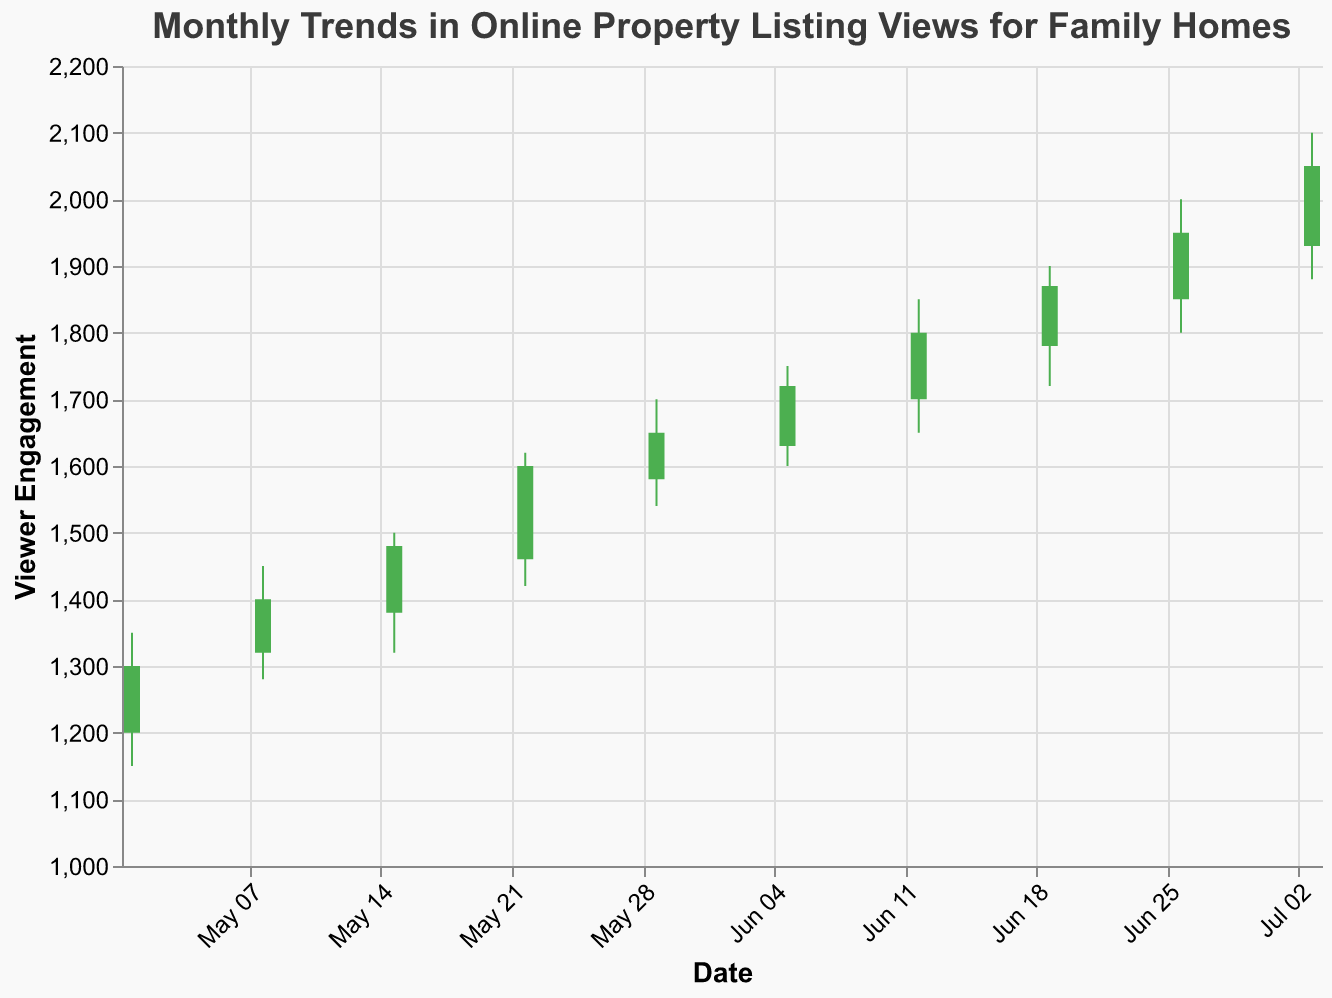What is the title of the chart? The title is at the top of the chart and clearly states the purpose of the visualization.
Answer: Monthly Trends in Online Property Listing Views for Family Homes How many data points are displayed in the chart? There are dates labeled on the x-axis, and each date likely corresponds to one data point. By counting the dates, we find there are 10 data points.
Answer: 10 What are the colors used to represent increasing and decreasing viewer engagement? In the chart, a green color is used to represent an increase where the close value is higher than the open value, and a red color is used for a decrease where the close value is lower than the open value.
Answer: Green and Red On which date was viewer engagement the highest during the month of May? By examining the "High" values for dates in May and comparing them, we find that the highest engagement was on May 22 with a high value of 1620.
Answer: May 22 Which week had the lowest level of viewer engagement? We need to find the minimum "Low" value across all data points and identify the corresponding date. The lowest engagement is on May 1 with a low value of 1150.
Answer: May 1 Calculate the difference between the highest and lowest viewer engagement in June. To find this, identify the highest high and the lowest low values in June. The highest high is 2000 (June 26) and the lowest low is 1600 (June 5). The difference is 2000 - 1600 = 400.
Answer: 400 Which week experienced the greatest increase in viewer engagement? We need to find the week where the difference between the close and open values is the maximum. The week of June 19 had an increase of 90 (Close - Open = 1870 - 1780).
Answer: June 19 On which date did the viewer engagement reach a close of 1950? By checking the "Close" column and matching it with the dates, we find that on June 26, the viewer engagement closed at 1950.
Answer: June 26 How does viewer engagement on June 12 compare to that on May 29? Compare the "Close" values for June 12 (1800) and May 29 (1650). Engagement on June 12 is higher.
Answer: June 12 is higher Identify the trend in viewer engagement from mid-May to early July. Observing the "Close" values from mid-May (May 15) to early July (July 3), the trend shows a steady increase from 1480 to 2050.
Answer: Increasing trend 